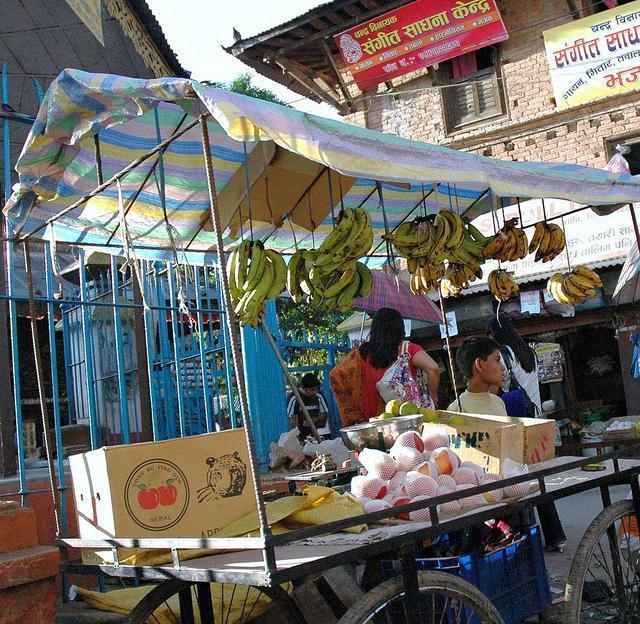How many people are there?
Give a very brief answer. 3. How many bananas are in the picture?
Give a very brief answer. 2. How many buses are in the picture?
Give a very brief answer. 0. 